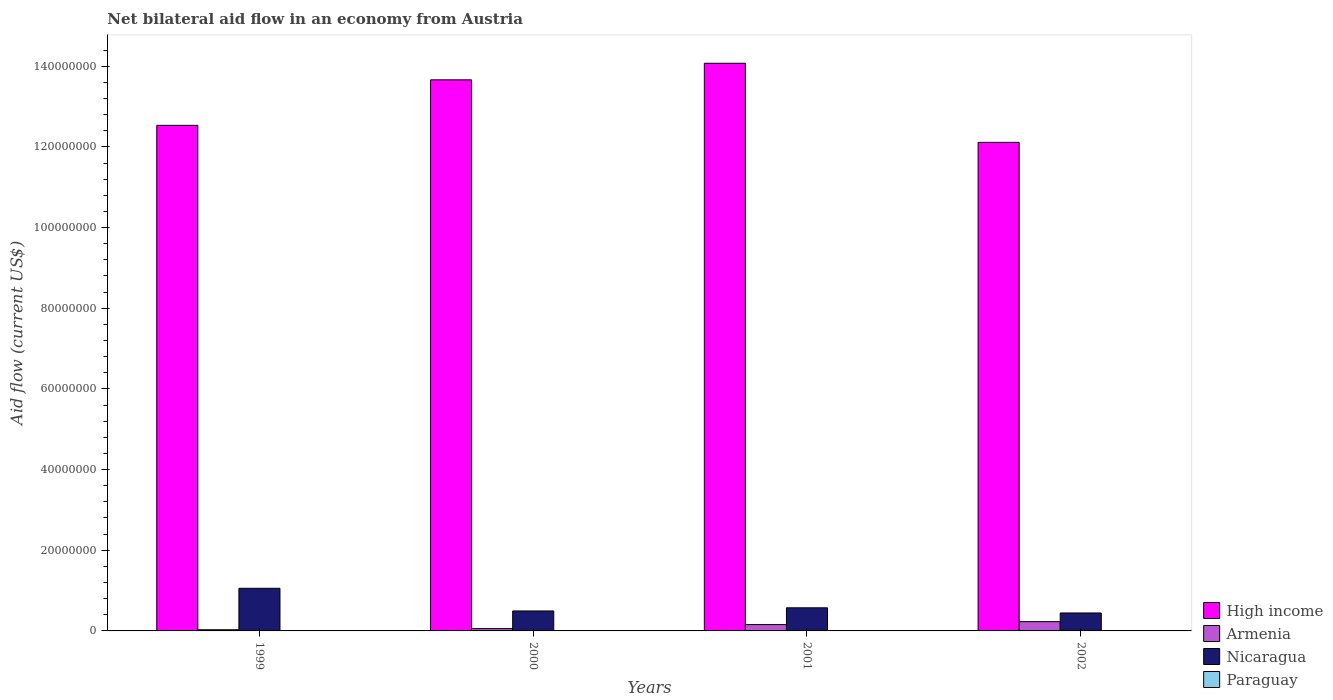How many different coloured bars are there?
Provide a short and direct response. 4. How many bars are there on the 2nd tick from the left?
Give a very brief answer. 4. How many bars are there on the 2nd tick from the right?
Give a very brief answer. 4. In how many cases, is the number of bars for a given year not equal to the number of legend labels?
Offer a terse response. 0. What is the net bilateral aid flow in Armenia in 2001?
Your answer should be very brief. 1.57e+06. Across all years, what is the maximum net bilateral aid flow in High income?
Give a very brief answer. 1.41e+08. Across all years, what is the minimum net bilateral aid flow in Nicaragua?
Provide a succinct answer. 4.45e+06. What is the difference between the net bilateral aid flow in Paraguay in 1999 and that in 2001?
Give a very brief answer. 10000. What is the difference between the net bilateral aid flow in Paraguay in 2001 and the net bilateral aid flow in High income in 2002?
Give a very brief answer. -1.21e+08. What is the average net bilateral aid flow in Nicaragua per year?
Provide a short and direct response. 6.42e+06. In the year 2001, what is the difference between the net bilateral aid flow in Nicaragua and net bilateral aid flow in High income?
Your answer should be compact. -1.35e+08. In how many years, is the net bilateral aid flow in Armenia greater than 72000000 US$?
Your answer should be very brief. 0. What is the ratio of the net bilateral aid flow in Armenia in 1999 to that in 2001?
Your response must be concise. 0.18. Is the difference between the net bilateral aid flow in Nicaragua in 2000 and 2001 greater than the difference between the net bilateral aid flow in High income in 2000 and 2001?
Provide a succinct answer. Yes. What is the difference between the highest and the second highest net bilateral aid flow in Paraguay?
Offer a terse response. 10000. What is the difference between the highest and the lowest net bilateral aid flow in High income?
Offer a terse response. 1.96e+07. In how many years, is the net bilateral aid flow in Nicaragua greater than the average net bilateral aid flow in Nicaragua taken over all years?
Give a very brief answer. 1. What does the 2nd bar from the left in 1999 represents?
Your answer should be very brief. Armenia. What does the 3rd bar from the right in 1999 represents?
Your response must be concise. Armenia. Is it the case that in every year, the sum of the net bilateral aid flow in High income and net bilateral aid flow in Nicaragua is greater than the net bilateral aid flow in Armenia?
Your answer should be compact. Yes. How many bars are there?
Your answer should be compact. 16. Are all the bars in the graph horizontal?
Ensure brevity in your answer.  No. How many years are there in the graph?
Make the answer very short. 4. What is the difference between two consecutive major ticks on the Y-axis?
Your response must be concise. 2.00e+07. Are the values on the major ticks of Y-axis written in scientific E-notation?
Your answer should be compact. No. Does the graph contain grids?
Give a very brief answer. No. How many legend labels are there?
Your response must be concise. 4. How are the legend labels stacked?
Ensure brevity in your answer.  Vertical. What is the title of the graph?
Keep it short and to the point. Net bilateral aid flow in an economy from Austria. What is the label or title of the X-axis?
Ensure brevity in your answer.  Years. What is the Aid flow (current US$) of High income in 1999?
Ensure brevity in your answer.  1.25e+08. What is the Aid flow (current US$) in Armenia in 1999?
Offer a very short reply. 2.90e+05. What is the Aid flow (current US$) of Nicaragua in 1999?
Ensure brevity in your answer.  1.06e+07. What is the Aid flow (current US$) in High income in 2000?
Offer a very short reply. 1.37e+08. What is the Aid flow (current US$) of Armenia in 2000?
Provide a succinct answer. 5.80e+05. What is the Aid flow (current US$) of Nicaragua in 2000?
Offer a terse response. 4.95e+06. What is the Aid flow (current US$) in Paraguay in 2000?
Your answer should be very brief. 10000. What is the Aid flow (current US$) of High income in 2001?
Your answer should be compact. 1.41e+08. What is the Aid flow (current US$) in Armenia in 2001?
Make the answer very short. 1.57e+06. What is the Aid flow (current US$) of Nicaragua in 2001?
Ensure brevity in your answer.  5.73e+06. What is the Aid flow (current US$) in Paraguay in 2001?
Make the answer very short. 10000. What is the Aid flow (current US$) of High income in 2002?
Offer a very short reply. 1.21e+08. What is the Aid flow (current US$) of Armenia in 2002?
Your response must be concise. 2.30e+06. What is the Aid flow (current US$) in Nicaragua in 2002?
Offer a terse response. 4.45e+06. Across all years, what is the maximum Aid flow (current US$) of High income?
Your answer should be compact. 1.41e+08. Across all years, what is the maximum Aid flow (current US$) in Armenia?
Give a very brief answer. 2.30e+06. Across all years, what is the maximum Aid flow (current US$) in Nicaragua?
Your answer should be very brief. 1.06e+07. Across all years, what is the maximum Aid flow (current US$) of Paraguay?
Offer a terse response. 2.00e+04. Across all years, what is the minimum Aid flow (current US$) in High income?
Keep it short and to the point. 1.21e+08. Across all years, what is the minimum Aid flow (current US$) of Armenia?
Offer a very short reply. 2.90e+05. Across all years, what is the minimum Aid flow (current US$) of Nicaragua?
Your answer should be compact. 4.45e+06. What is the total Aid flow (current US$) of High income in the graph?
Your answer should be very brief. 5.24e+08. What is the total Aid flow (current US$) in Armenia in the graph?
Keep it short and to the point. 4.74e+06. What is the total Aid flow (current US$) in Nicaragua in the graph?
Offer a very short reply. 2.57e+07. What is the difference between the Aid flow (current US$) of High income in 1999 and that in 2000?
Keep it short and to the point. -1.13e+07. What is the difference between the Aid flow (current US$) in Armenia in 1999 and that in 2000?
Make the answer very short. -2.90e+05. What is the difference between the Aid flow (current US$) of Nicaragua in 1999 and that in 2000?
Offer a very short reply. 5.62e+06. What is the difference between the Aid flow (current US$) in High income in 1999 and that in 2001?
Provide a short and direct response. -1.54e+07. What is the difference between the Aid flow (current US$) of Armenia in 1999 and that in 2001?
Offer a terse response. -1.28e+06. What is the difference between the Aid flow (current US$) of Nicaragua in 1999 and that in 2001?
Your response must be concise. 4.84e+06. What is the difference between the Aid flow (current US$) in Paraguay in 1999 and that in 2001?
Provide a short and direct response. 10000. What is the difference between the Aid flow (current US$) in High income in 1999 and that in 2002?
Offer a very short reply. 4.22e+06. What is the difference between the Aid flow (current US$) in Armenia in 1999 and that in 2002?
Your answer should be very brief. -2.01e+06. What is the difference between the Aid flow (current US$) of Nicaragua in 1999 and that in 2002?
Give a very brief answer. 6.12e+06. What is the difference between the Aid flow (current US$) of Paraguay in 1999 and that in 2002?
Provide a short and direct response. 10000. What is the difference between the Aid flow (current US$) of High income in 2000 and that in 2001?
Make the answer very short. -4.11e+06. What is the difference between the Aid flow (current US$) in Armenia in 2000 and that in 2001?
Your answer should be very brief. -9.90e+05. What is the difference between the Aid flow (current US$) in Nicaragua in 2000 and that in 2001?
Give a very brief answer. -7.80e+05. What is the difference between the Aid flow (current US$) of High income in 2000 and that in 2002?
Your response must be concise. 1.55e+07. What is the difference between the Aid flow (current US$) in Armenia in 2000 and that in 2002?
Your answer should be compact. -1.72e+06. What is the difference between the Aid flow (current US$) in Nicaragua in 2000 and that in 2002?
Ensure brevity in your answer.  5.00e+05. What is the difference between the Aid flow (current US$) of Paraguay in 2000 and that in 2002?
Provide a succinct answer. 0. What is the difference between the Aid flow (current US$) of High income in 2001 and that in 2002?
Ensure brevity in your answer.  1.96e+07. What is the difference between the Aid flow (current US$) in Armenia in 2001 and that in 2002?
Make the answer very short. -7.30e+05. What is the difference between the Aid flow (current US$) in Nicaragua in 2001 and that in 2002?
Your answer should be very brief. 1.28e+06. What is the difference between the Aid flow (current US$) of Paraguay in 2001 and that in 2002?
Provide a succinct answer. 0. What is the difference between the Aid flow (current US$) in High income in 1999 and the Aid flow (current US$) in Armenia in 2000?
Offer a very short reply. 1.25e+08. What is the difference between the Aid flow (current US$) of High income in 1999 and the Aid flow (current US$) of Nicaragua in 2000?
Your response must be concise. 1.20e+08. What is the difference between the Aid flow (current US$) in High income in 1999 and the Aid flow (current US$) in Paraguay in 2000?
Your answer should be compact. 1.25e+08. What is the difference between the Aid flow (current US$) of Armenia in 1999 and the Aid flow (current US$) of Nicaragua in 2000?
Your response must be concise. -4.66e+06. What is the difference between the Aid flow (current US$) in Armenia in 1999 and the Aid flow (current US$) in Paraguay in 2000?
Your answer should be very brief. 2.80e+05. What is the difference between the Aid flow (current US$) of Nicaragua in 1999 and the Aid flow (current US$) of Paraguay in 2000?
Give a very brief answer. 1.06e+07. What is the difference between the Aid flow (current US$) of High income in 1999 and the Aid flow (current US$) of Armenia in 2001?
Your answer should be very brief. 1.24e+08. What is the difference between the Aid flow (current US$) of High income in 1999 and the Aid flow (current US$) of Nicaragua in 2001?
Ensure brevity in your answer.  1.20e+08. What is the difference between the Aid flow (current US$) in High income in 1999 and the Aid flow (current US$) in Paraguay in 2001?
Provide a short and direct response. 1.25e+08. What is the difference between the Aid flow (current US$) of Armenia in 1999 and the Aid flow (current US$) of Nicaragua in 2001?
Your answer should be very brief. -5.44e+06. What is the difference between the Aid flow (current US$) in Armenia in 1999 and the Aid flow (current US$) in Paraguay in 2001?
Provide a succinct answer. 2.80e+05. What is the difference between the Aid flow (current US$) in Nicaragua in 1999 and the Aid flow (current US$) in Paraguay in 2001?
Offer a terse response. 1.06e+07. What is the difference between the Aid flow (current US$) in High income in 1999 and the Aid flow (current US$) in Armenia in 2002?
Offer a very short reply. 1.23e+08. What is the difference between the Aid flow (current US$) in High income in 1999 and the Aid flow (current US$) in Nicaragua in 2002?
Your response must be concise. 1.21e+08. What is the difference between the Aid flow (current US$) in High income in 1999 and the Aid flow (current US$) in Paraguay in 2002?
Ensure brevity in your answer.  1.25e+08. What is the difference between the Aid flow (current US$) in Armenia in 1999 and the Aid flow (current US$) in Nicaragua in 2002?
Ensure brevity in your answer.  -4.16e+06. What is the difference between the Aid flow (current US$) of Armenia in 1999 and the Aid flow (current US$) of Paraguay in 2002?
Your answer should be compact. 2.80e+05. What is the difference between the Aid flow (current US$) in Nicaragua in 1999 and the Aid flow (current US$) in Paraguay in 2002?
Keep it short and to the point. 1.06e+07. What is the difference between the Aid flow (current US$) of High income in 2000 and the Aid flow (current US$) of Armenia in 2001?
Ensure brevity in your answer.  1.35e+08. What is the difference between the Aid flow (current US$) of High income in 2000 and the Aid flow (current US$) of Nicaragua in 2001?
Provide a short and direct response. 1.31e+08. What is the difference between the Aid flow (current US$) of High income in 2000 and the Aid flow (current US$) of Paraguay in 2001?
Your answer should be compact. 1.37e+08. What is the difference between the Aid flow (current US$) of Armenia in 2000 and the Aid flow (current US$) of Nicaragua in 2001?
Provide a short and direct response. -5.15e+06. What is the difference between the Aid flow (current US$) in Armenia in 2000 and the Aid flow (current US$) in Paraguay in 2001?
Make the answer very short. 5.70e+05. What is the difference between the Aid flow (current US$) of Nicaragua in 2000 and the Aid flow (current US$) of Paraguay in 2001?
Make the answer very short. 4.94e+06. What is the difference between the Aid flow (current US$) in High income in 2000 and the Aid flow (current US$) in Armenia in 2002?
Make the answer very short. 1.34e+08. What is the difference between the Aid flow (current US$) in High income in 2000 and the Aid flow (current US$) in Nicaragua in 2002?
Your answer should be very brief. 1.32e+08. What is the difference between the Aid flow (current US$) of High income in 2000 and the Aid flow (current US$) of Paraguay in 2002?
Your answer should be compact. 1.37e+08. What is the difference between the Aid flow (current US$) in Armenia in 2000 and the Aid flow (current US$) in Nicaragua in 2002?
Provide a short and direct response. -3.87e+06. What is the difference between the Aid flow (current US$) in Armenia in 2000 and the Aid flow (current US$) in Paraguay in 2002?
Offer a terse response. 5.70e+05. What is the difference between the Aid flow (current US$) of Nicaragua in 2000 and the Aid flow (current US$) of Paraguay in 2002?
Your response must be concise. 4.94e+06. What is the difference between the Aid flow (current US$) of High income in 2001 and the Aid flow (current US$) of Armenia in 2002?
Provide a short and direct response. 1.38e+08. What is the difference between the Aid flow (current US$) of High income in 2001 and the Aid flow (current US$) of Nicaragua in 2002?
Ensure brevity in your answer.  1.36e+08. What is the difference between the Aid flow (current US$) of High income in 2001 and the Aid flow (current US$) of Paraguay in 2002?
Make the answer very short. 1.41e+08. What is the difference between the Aid flow (current US$) in Armenia in 2001 and the Aid flow (current US$) in Nicaragua in 2002?
Offer a very short reply. -2.88e+06. What is the difference between the Aid flow (current US$) in Armenia in 2001 and the Aid flow (current US$) in Paraguay in 2002?
Provide a succinct answer. 1.56e+06. What is the difference between the Aid flow (current US$) of Nicaragua in 2001 and the Aid flow (current US$) of Paraguay in 2002?
Keep it short and to the point. 5.72e+06. What is the average Aid flow (current US$) of High income per year?
Give a very brief answer. 1.31e+08. What is the average Aid flow (current US$) of Armenia per year?
Give a very brief answer. 1.18e+06. What is the average Aid flow (current US$) in Nicaragua per year?
Your answer should be very brief. 6.42e+06. What is the average Aid flow (current US$) in Paraguay per year?
Provide a short and direct response. 1.25e+04. In the year 1999, what is the difference between the Aid flow (current US$) in High income and Aid flow (current US$) in Armenia?
Your answer should be compact. 1.25e+08. In the year 1999, what is the difference between the Aid flow (current US$) of High income and Aid flow (current US$) of Nicaragua?
Make the answer very short. 1.15e+08. In the year 1999, what is the difference between the Aid flow (current US$) of High income and Aid flow (current US$) of Paraguay?
Your answer should be very brief. 1.25e+08. In the year 1999, what is the difference between the Aid flow (current US$) of Armenia and Aid flow (current US$) of Nicaragua?
Keep it short and to the point. -1.03e+07. In the year 1999, what is the difference between the Aid flow (current US$) of Nicaragua and Aid flow (current US$) of Paraguay?
Offer a terse response. 1.06e+07. In the year 2000, what is the difference between the Aid flow (current US$) in High income and Aid flow (current US$) in Armenia?
Offer a terse response. 1.36e+08. In the year 2000, what is the difference between the Aid flow (current US$) in High income and Aid flow (current US$) in Nicaragua?
Your response must be concise. 1.32e+08. In the year 2000, what is the difference between the Aid flow (current US$) in High income and Aid flow (current US$) in Paraguay?
Ensure brevity in your answer.  1.37e+08. In the year 2000, what is the difference between the Aid flow (current US$) in Armenia and Aid flow (current US$) in Nicaragua?
Your response must be concise. -4.37e+06. In the year 2000, what is the difference between the Aid flow (current US$) of Armenia and Aid flow (current US$) of Paraguay?
Offer a very short reply. 5.70e+05. In the year 2000, what is the difference between the Aid flow (current US$) in Nicaragua and Aid flow (current US$) in Paraguay?
Keep it short and to the point. 4.94e+06. In the year 2001, what is the difference between the Aid flow (current US$) in High income and Aid flow (current US$) in Armenia?
Offer a very short reply. 1.39e+08. In the year 2001, what is the difference between the Aid flow (current US$) of High income and Aid flow (current US$) of Nicaragua?
Give a very brief answer. 1.35e+08. In the year 2001, what is the difference between the Aid flow (current US$) in High income and Aid flow (current US$) in Paraguay?
Your answer should be very brief. 1.41e+08. In the year 2001, what is the difference between the Aid flow (current US$) of Armenia and Aid flow (current US$) of Nicaragua?
Provide a succinct answer. -4.16e+06. In the year 2001, what is the difference between the Aid flow (current US$) of Armenia and Aid flow (current US$) of Paraguay?
Offer a terse response. 1.56e+06. In the year 2001, what is the difference between the Aid flow (current US$) of Nicaragua and Aid flow (current US$) of Paraguay?
Offer a very short reply. 5.72e+06. In the year 2002, what is the difference between the Aid flow (current US$) of High income and Aid flow (current US$) of Armenia?
Offer a very short reply. 1.19e+08. In the year 2002, what is the difference between the Aid flow (current US$) of High income and Aid flow (current US$) of Nicaragua?
Keep it short and to the point. 1.17e+08. In the year 2002, what is the difference between the Aid flow (current US$) of High income and Aid flow (current US$) of Paraguay?
Offer a very short reply. 1.21e+08. In the year 2002, what is the difference between the Aid flow (current US$) of Armenia and Aid flow (current US$) of Nicaragua?
Ensure brevity in your answer.  -2.15e+06. In the year 2002, what is the difference between the Aid flow (current US$) of Armenia and Aid flow (current US$) of Paraguay?
Provide a short and direct response. 2.29e+06. In the year 2002, what is the difference between the Aid flow (current US$) in Nicaragua and Aid flow (current US$) in Paraguay?
Give a very brief answer. 4.44e+06. What is the ratio of the Aid flow (current US$) of High income in 1999 to that in 2000?
Offer a terse response. 0.92. What is the ratio of the Aid flow (current US$) of Armenia in 1999 to that in 2000?
Provide a short and direct response. 0.5. What is the ratio of the Aid flow (current US$) of Nicaragua in 1999 to that in 2000?
Keep it short and to the point. 2.14. What is the ratio of the Aid flow (current US$) of Paraguay in 1999 to that in 2000?
Offer a very short reply. 2. What is the ratio of the Aid flow (current US$) of High income in 1999 to that in 2001?
Provide a short and direct response. 0.89. What is the ratio of the Aid flow (current US$) of Armenia in 1999 to that in 2001?
Give a very brief answer. 0.18. What is the ratio of the Aid flow (current US$) in Nicaragua in 1999 to that in 2001?
Offer a very short reply. 1.84. What is the ratio of the Aid flow (current US$) in Paraguay in 1999 to that in 2001?
Your answer should be very brief. 2. What is the ratio of the Aid flow (current US$) of High income in 1999 to that in 2002?
Provide a succinct answer. 1.03. What is the ratio of the Aid flow (current US$) in Armenia in 1999 to that in 2002?
Ensure brevity in your answer.  0.13. What is the ratio of the Aid flow (current US$) of Nicaragua in 1999 to that in 2002?
Your answer should be very brief. 2.38. What is the ratio of the Aid flow (current US$) of High income in 2000 to that in 2001?
Offer a very short reply. 0.97. What is the ratio of the Aid flow (current US$) of Armenia in 2000 to that in 2001?
Offer a terse response. 0.37. What is the ratio of the Aid flow (current US$) of Nicaragua in 2000 to that in 2001?
Offer a very short reply. 0.86. What is the ratio of the Aid flow (current US$) in High income in 2000 to that in 2002?
Make the answer very short. 1.13. What is the ratio of the Aid flow (current US$) in Armenia in 2000 to that in 2002?
Provide a short and direct response. 0.25. What is the ratio of the Aid flow (current US$) of Nicaragua in 2000 to that in 2002?
Give a very brief answer. 1.11. What is the ratio of the Aid flow (current US$) in Paraguay in 2000 to that in 2002?
Offer a very short reply. 1. What is the ratio of the Aid flow (current US$) of High income in 2001 to that in 2002?
Your answer should be very brief. 1.16. What is the ratio of the Aid flow (current US$) of Armenia in 2001 to that in 2002?
Give a very brief answer. 0.68. What is the ratio of the Aid flow (current US$) of Nicaragua in 2001 to that in 2002?
Provide a succinct answer. 1.29. What is the difference between the highest and the second highest Aid flow (current US$) of High income?
Your response must be concise. 4.11e+06. What is the difference between the highest and the second highest Aid flow (current US$) in Armenia?
Your answer should be compact. 7.30e+05. What is the difference between the highest and the second highest Aid flow (current US$) of Nicaragua?
Keep it short and to the point. 4.84e+06. What is the difference between the highest and the second highest Aid flow (current US$) of Paraguay?
Provide a short and direct response. 10000. What is the difference between the highest and the lowest Aid flow (current US$) in High income?
Your answer should be compact. 1.96e+07. What is the difference between the highest and the lowest Aid flow (current US$) in Armenia?
Your response must be concise. 2.01e+06. What is the difference between the highest and the lowest Aid flow (current US$) of Nicaragua?
Your answer should be compact. 6.12e+06. 